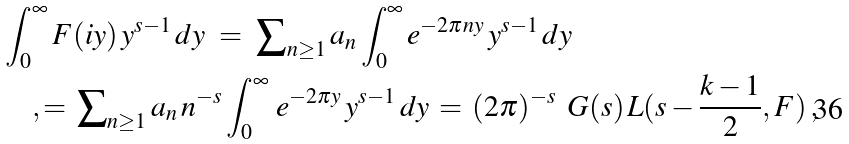<formula> <loc_0><loc_0><loc_500><loc_500>& \int _ { 0 } ^ { \infty } F ( i y ) \, y ^ { s - 1 } \, d y \ = \ { \sum } _ { n \geq 1 } \, a _ { n } \int _ { 0 } ^ { \infty } e ^ { - 2 \pi n y } \, y ^ { s - 1 } \, d y \\ & \quad , = \, { \sum } _ { n \geq 1 } \, a _ { n } \, n ^ { - s } \int _ { 0 } ^ { \infty } \, e ^ { - 2 \pi y } \, y ^ { s - 1 } \, d y \, = \, ( 2 \pi ) ^ { - s } \, \ G ( s ) \, L ( s - \frac { k - 1 } { 2 } , F ) \, ,</formula> 